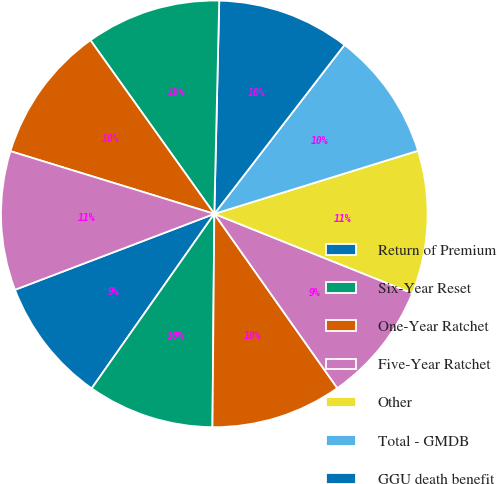<chart> <loc_0><loc_0><loc_500><loc_500><pie_chart><fcel>Return of Premium<fcel>Six-Year Reset<fcel>One-Year Ratchet<fcel>Five-Year Ratchet<fcel>Other<fcel>Total - GMDB<fcel>GGU death benefit<fcel>GMIB<fcel>GMWB<fcel>GMWB for life<nl><fcel>9.46%<fcel>9.61%<fcel>9.92%<fcel>9.15%<fcel>10.85%<fcel>9.77%<fcel>10.08%<fcel>10.23%<fcel>10.39%<fcel>10.54%<nl></chart> 